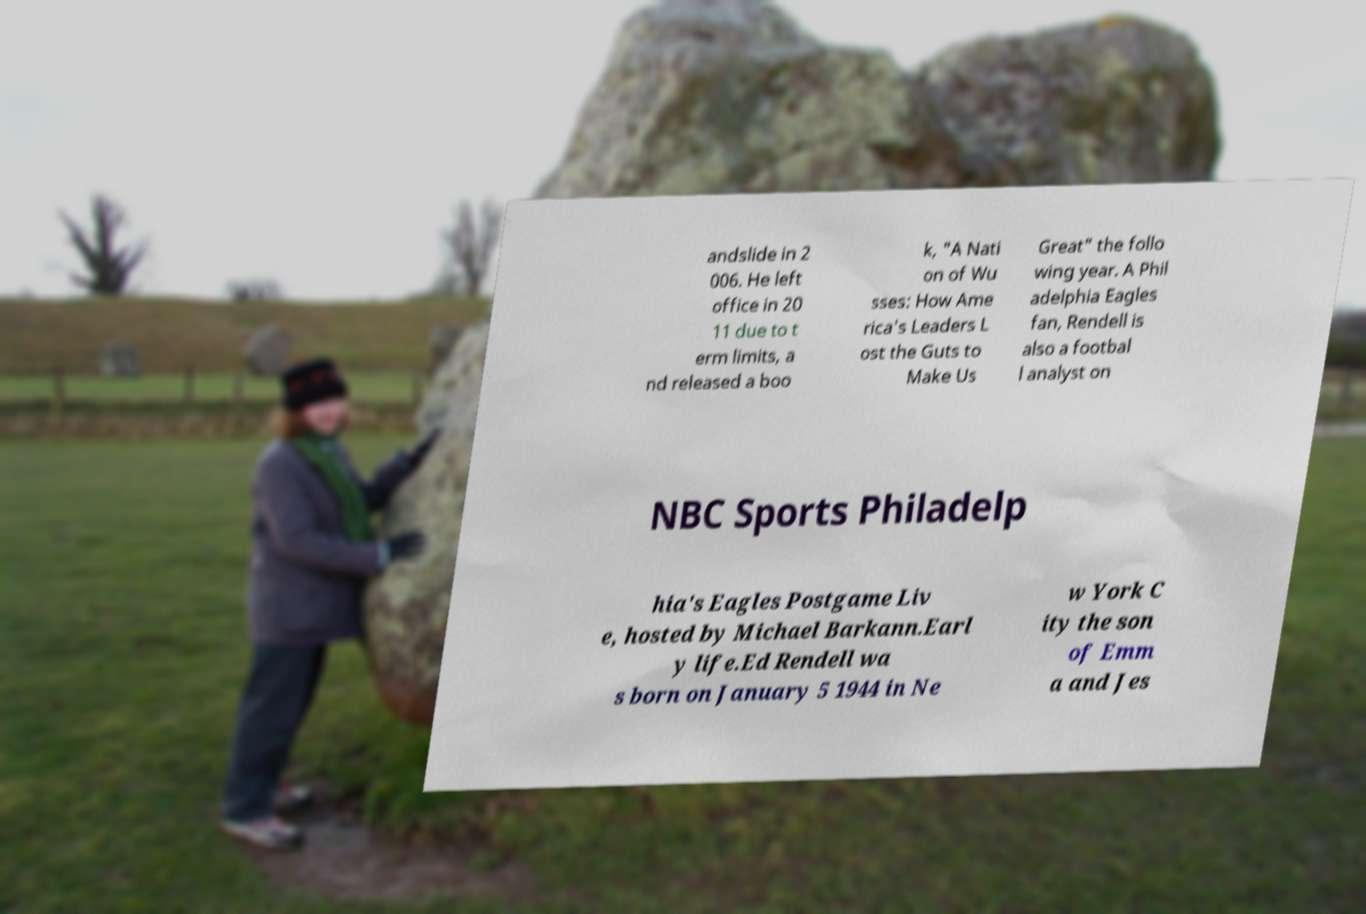Could you extract and type out the text from this image? andslide in 2 006. He left office in 20 11 due to t erm limits, a nd released a boo k, "A Nati on of Wu sses: How Ame rica's Leaders L ost the Guts to Make Us Great" the follo wing year. A Phil adelphia Eagles fan, Rendell is also a footbal l analyst on NBC Sports Philadelp hia's Eagles Postgame Liv e, hosted by Michael Barkann.Earl y life.Ed Rendell wa s born on January 5 1944 in Ne w York C ity the son of Emm a and Jes 